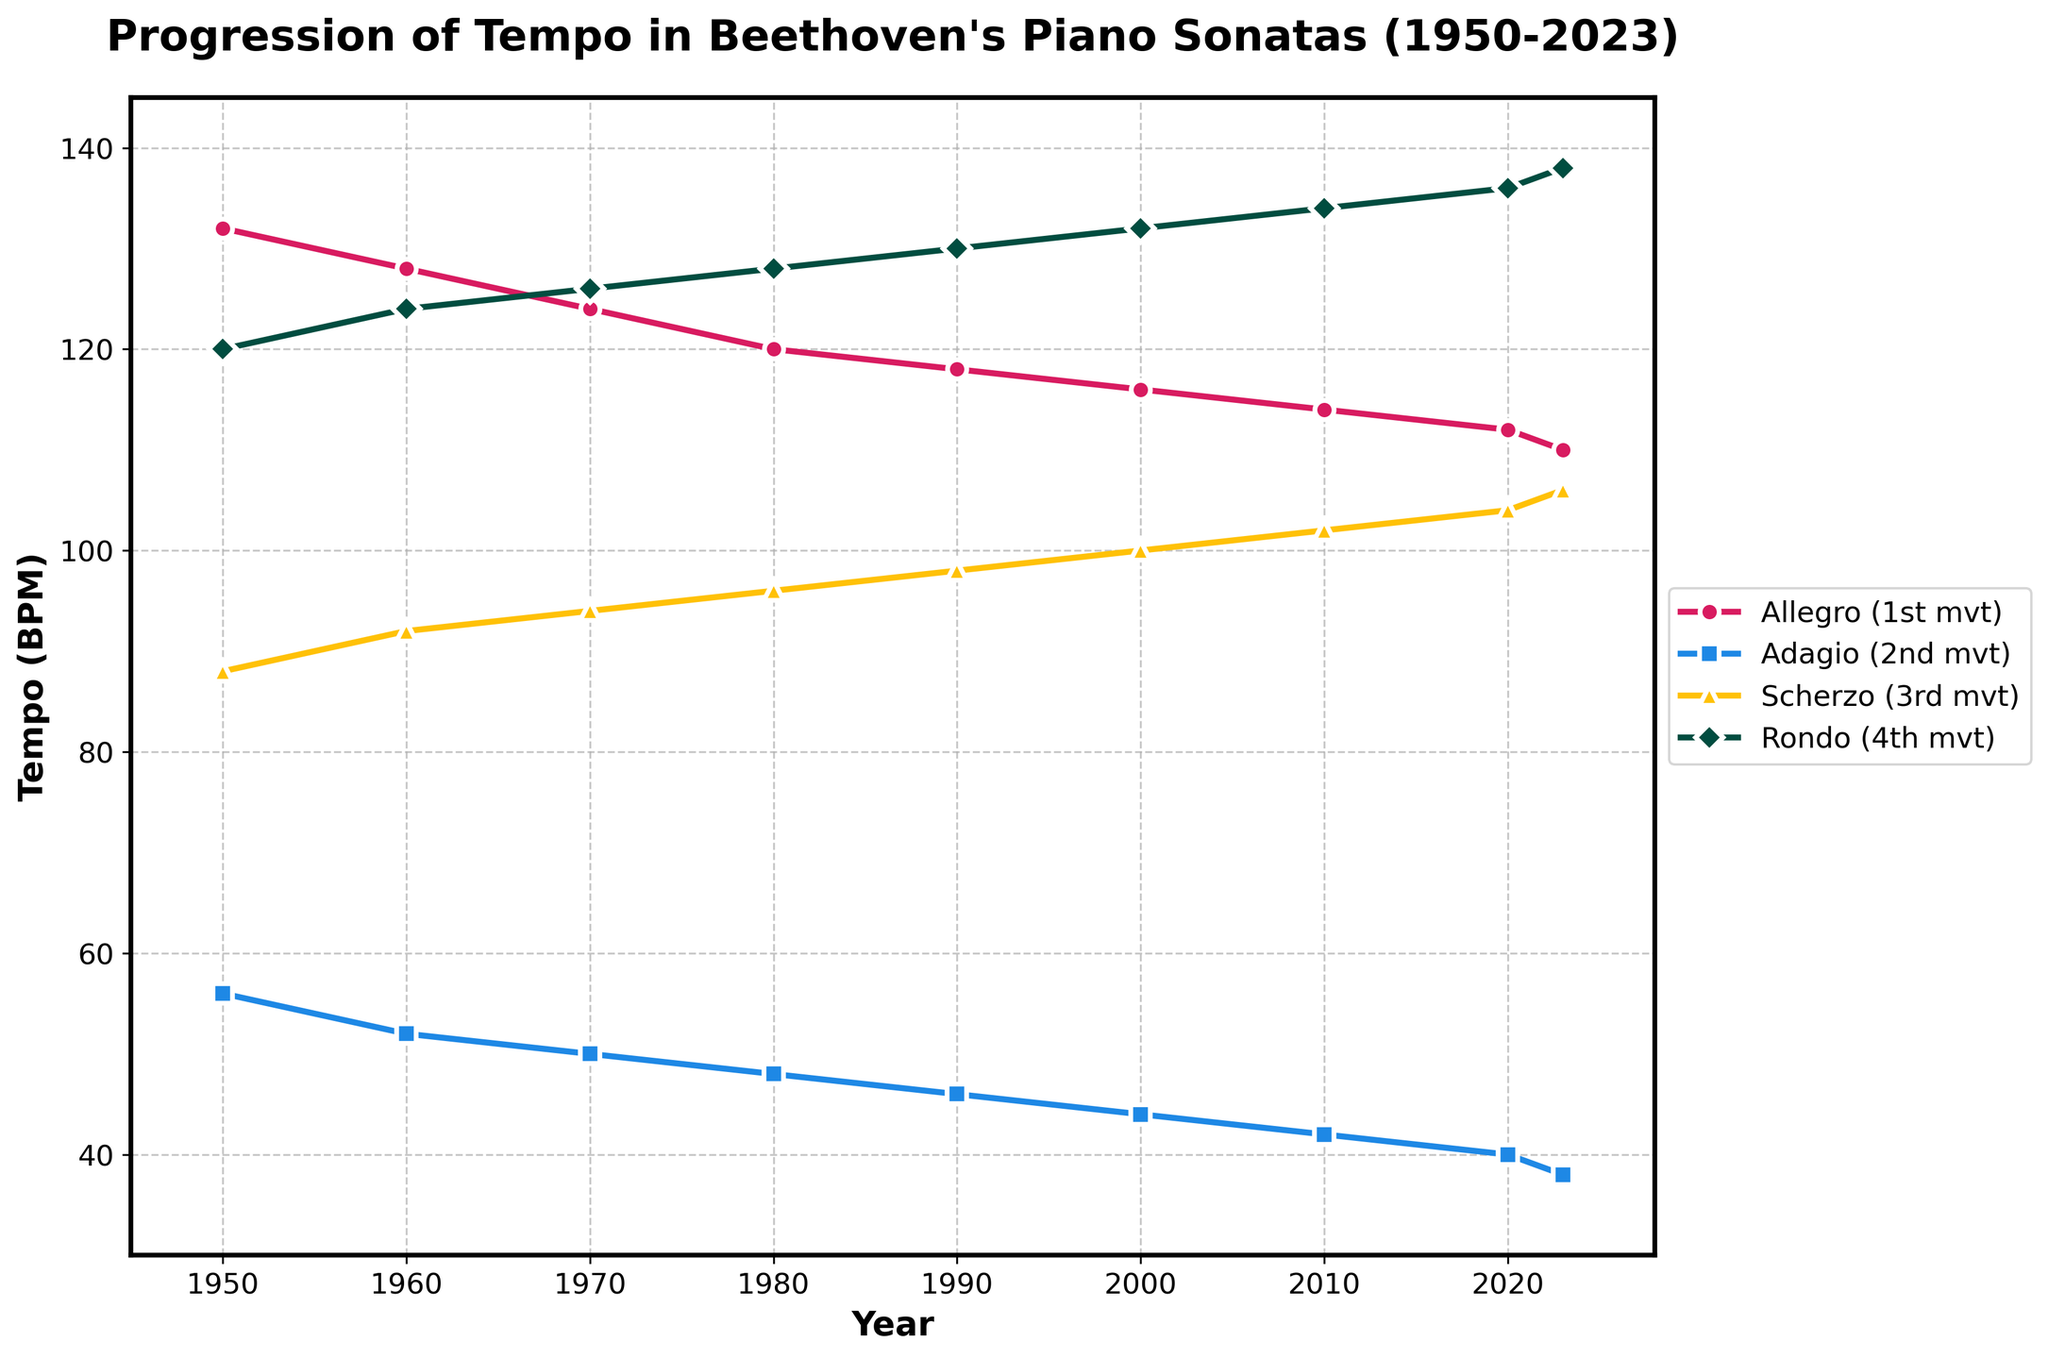What is the tempo of the Allegro (1st mvt) in 1990? Locate 1990 on the x-axis and find the corresponding value for the Allegro (1st mvt) line, which is represented by the pink line with circular markers.
Answer: 118 BPM Which movement has the slowest tempo in 2020? Locate the year 2020 on the x-axis, and then identify the lowest point among the four lines. The blue line with square markers for the Adagio (2nd mvt) is the lowest.
Answer: Adagio (2nd mvt) How does the tempo of the Scherzo (3rd mvt) in 1980 compare to the Rondo (4th mvt) in 1980? Locate 1980 on the x-axis, find the yellow line with triangular markers for Scherzo (3rd mvt) and the green line with diamond markers for Rondo (4th mvt). Compare the values: Scherzo (96 BPM) and Rondo (128 BPM).
Answer: Scherzo (3rd mvt) is slower What is the average tempo of the Adagio (2nd mvt) from 1950 to 2023? Sum the Adagio values from 1950 to 2023 (56+52+50+48+46+44+42+40+38) = 416. Divide by 9 (number of data points) to get the average, 416/9 ≈ 46.22.
Answer: ≈ 46.22 BPM In which year did the Rondo (4th mvt) tempo surpass 130 BPM for the first time? Trace the green line (Rondo) across the x-axis, noting when it first exceeds 130 BPM, which is between 1990 and 2000. The year is 2000.
Answer: 2000 What is the overall trend of the Allegro (1st mvt) tempo from 1950 to 2023? Observe the pink line with circular markers representing the Allegro (1st mvt) tempo over time. Notice the steady decline from 132 BPM in 1950 to 110 BPM in 2023.
Answer: Downward trend Which movement shows the smallest change in tempo from 1950 to 2023? Calculate the difference between 1950 and 2023 for each movement: Allegro (132-110=22), Adagio (56-38=18), Scherzo (88-106=18), and Rondo (120-138=18). Adagio, Scherzo, and Rondo changes are equal (smallest change: 18 BPM).
Answer: Adagio (2nd mvt), Scherzo (3rd mvt), Rondo (4th mvt) How many movements had a tempo of 100 BPM or greater in 1980? For the year 1980, check each movement's tempo: Allegro (120), Adagio (48), Scherzo (96), Rondo (128). Count the movements with 100 BPM or more.
Answer: 2 movements Is the tempo of the Adagio (2nd mvt) in 2023 greater than the tempo of the Rondo (4th mvt) in 1950? Compare the Adagio (2nd mvt) tempo in 2023 (38 BPM) with the Rondo (4th mvt) tempo in 1950 (120 BPM).
Answer: No 